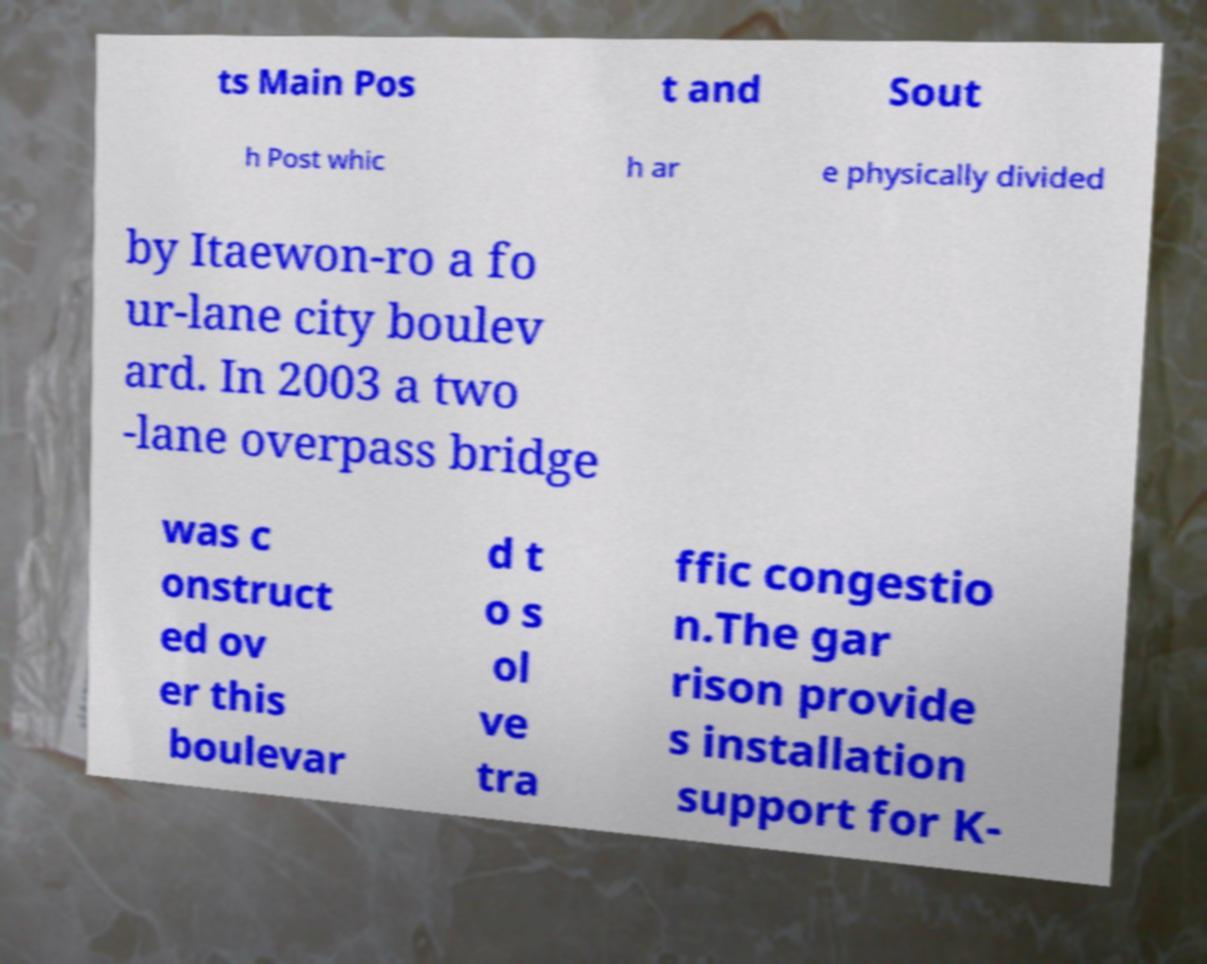Please identify and transcribe the text found in this image. ts Main Pos t and Sout h Post whic h ar e physically divided by Itaewon-ro a fo ur-lane city boulev ard. In 2003 a two -lane overpass bridge was c onstruct ed ov er this boulevar d t o s ol ve tra ffic congestio n.The gar rison provide s installation support for K- 